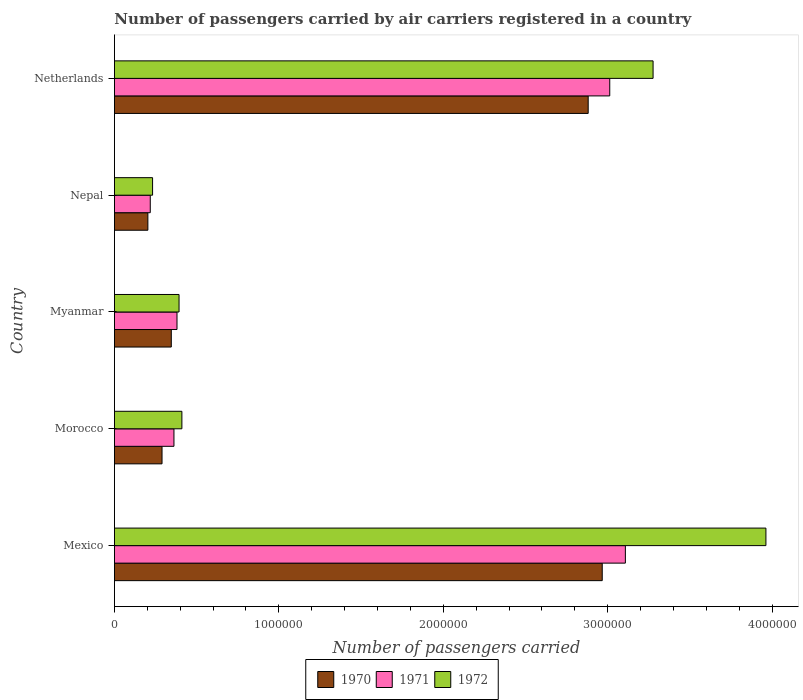Are the number of bars on each tick of the Y-axis equal?
Offer a terse response. Yes. How many bars are there on the 3rd tick from the top?
Provide a succinct answer. 3. How many bars are there on the 1st tick from the bottom?
Provide a short and direct response. 3. What is the label of the 2nd group of bars from the top?
Provide a short and direct response. Nepal. What is the number of passengers carried by air carriers in 1971 in Morocco?
Your answer should be very brief. 3.62e+05. Across all countries, what is the maximum number of passengers carried by air carriers in 1970?
Ensure brevity in your answer.  2.97e+06. Across all countries, what is the minimum number of passengers carried by air carriers in 1972?
Provide a short and direct response. 2.32e+05. In which country was the number of passengers carried by air carriers in 1971 maximum?
Your response must be concise. Mexico. In which country was the number of passengers carried by air carriers in 1971 minimum?
Offer a very short reply. Nepal. What is the total number of passengers carried by air carriers in 1972 in the graph?
Offer a terse response. 8.27e+06. What is the difference between the number of passengers carried by air carriers in 1971 in Morocco and that in Myanmar?
Offer a very short reply. -1.85e+04. What is the difference between the number of passengers carried by air carriers in 1970 in Myanmar and the number of passengers carried by air carriers in 1972 in Nepal?
Keep it short and to the point. 1.14e+05. What is the average number of passengers carried by air carriers in 1970 per country?
Ensure brevity in your answer.  1.34e+06. What is the difference between the number of passengers carried by air carriers in 1970 and number of passengers carried by air carriers in 1971 in Mexico?
Your answer should be very brief. -1.41e+05. In how many countries, is the number of passengers carried by air carriers in 1972 greater than 400000 ?
Ensure brevity in your answer.  3. What is the ratio of the number of passengers carried by air carriers in 1971 in Mexico to that in Myanmar?
Provide a succinct answer. 8.17. Is the number of passengers carried by air carriers in 1972 in Mexico less than that in Nepal?
Offer a very short reply. No. Is the difference between the number of passengers carried by air carriers in 1970 in Morocco and Nepal greater than the difference between the number of passengers carried by air carriers in 1971 in Morocco and Nepal?
Keep it short and to the point. No. What is the difference between the highest and the second highest number of passengers carried by air carriers in 1971?
Your answer should be very brief. 9.50e+04. What is the difference between the highest and the lowest number of passengers carried by air carriers in 1971?
Keep it short and to the point. 2.89e+06. In how many countries, is the number of passengers carried by air carriers in 1972 greater than the average number of passengers carried by air carriers in 1972 taken over all countries?
Keep it short and to the point. 2. What does the 3rd bar from the top in Mexico represents?
Provide a succinct answer. 1970. What does the 2nd bar from the bottom in Mexico represents?
Your answer should be compact. 1971. How many bars are there?
Give a very brief answer. 15. How many countries are there in the graph?
Provide a short and direct response. 5. Does the graph contain any zero values?
Your answer should be compact. No. Where does the legend appear in the graph?
Your answer should be compact. Bottom center. How many legend labels are there?
Give a very brief answer. 3. What is the title of the graph?
Make the answer very short. Number of passengers carried by air carriers registered in a country. What is the label or title of the X-axis?
Your answer should be very brief. Number of passengers carried. What is the Number of passengers carried in 1970 in Mexico?
Your response must be concise. 2.97e+06. What is the Number of passengers carried in 1971 in Mexico?
Provide a short and direct response. 3.11e+06. What is the Number of passengers carried of 1972 in Mexico?
Keep it short and to the point. 3.96e+06. What is the Number of passengers carried in 1970 in Morocco?
Your answer should be compact. 2.90e+05. What is the Number of passengers carried of 1971 in Morocco?
Your answer should be very brief. 3.62e+05. What is the Number of passengers carried of 1972 in Morocco?
Give a very brief answer. 4.10e+05. What is the Number of passengers carried in 1970 in Myanmar?
Your answer should be compact. 3.46e+05. What is the Number of passengers carried of 1971 in Myanmar?
Ensure brevity in your answer.  3.80e+05. What is the Number of passengers carried in 1972 in Myanmar?
Provide a succinct answer. 3.93e+05. What is the Number of passengers carried in 1970 in Nepal?
Offer a very short reply. 2.03e+05. What is the Number of passengers carried in 1971 in Nepal?
Offer a terse response. 2.18e+05. What is the Number of passengers carried of 1972 in Nepal?
Provide a short and direct response. 2.32e+05. What is the Number of passengers carried of 1970 in Netherlands?
Ensure brevity in your answer.  2.88e+06. What is the Number of passengers carried in 1971 in Netherlands?
Offer a very short reply. 3.01e+06. What is the Number of passengers carried in 1972 in Netherlands?
Offer a terse response. 3.28e+06. Across all countries, what is the maximum Number of passengers carried in 1970?
Provide a short and direct response. 2.97e+06. Across all countries, what is the maximum Number of passengers carried in 1971?
Offer a very short reply. 3.11e+06. Across all countries, what is the maximum Number of passengers carried in 1972?
Keep it short and to the point. 3.96e+06. Across all countries, what is the minimum Number of passengers carried of 1970?
Your response must be concise. 2.03e+05. Across all countries, what is the minimum Number of passengers carried in 1971?
Ensure brevity in your answer.  2.18e+05. Across all countries, what is the minimum Number of passengers carried in 1972?
Your answer should be very brief. 2.32e+05. What is the total Number of passengers carried in 1970 in the graph?
Give a very brief answer. 6.69e+06. What is the total Number of passengers carried of 1971 in the graph?
Offer a very short reply. 7.08e+06. What is the total Number of passengers carried in 1972 in the graph?
Offer a terse response. 8.27e+06. What is the difference between the Number of passengers carried in 1970 in Mexico and that in Morocco?
Provide a succinct answer. 2.68e+06. What is the difference between the Number of passengers carried in 1971 in Mexico and that in Morocco?
Your response must be concise. 2.75e+06. What is the difference between the Number of passengers carried of 1972 in Mexico and that in Morocco?
Make the answer very short. 3.55e+06. What is the difference between the Number of passengers carried of 1970 in Mexico and that in Myanmar?
Make the answer very short. 2.62e+06. What is the difference between the Number of passengers carried of 1971 in Mexico and that in Myanmar?
Ensure brevity in your answer.  2.73e+06. What is the difference between the Number of passengers carried of 1972 in Mexico and that in Myanmar?
Offer a very short reply. 3.57e+06. What is the difference between the Number of passengers carried in 1970 in Mexico and that in Nepal?
Provide a succinct answer. 2.76e+06. What is the difference between the Number of passengers carried of 1971 in Mexico and that in Nepal?
Provide a succinct answer. 2.89e+06. What is the difference between the Number of passengers carried of 1972 in Mexico and that in Nepal?
Keep it short and to the point. 3.73e+06. What is the difference between the Number of passengers carried of 1970 in Mexico and that in Netherlands?
Give a very brief answer. 8.55e+04. What is the difference between the Number of passengers carried of 1971 in Mexico and that in Netherlands?
Keep it short and to the point. 9.50e+04. What is the difference between the Number of passengers carried of 1972 in Mexico and that in Netherlands?
Offer a terse response. 6.86e+05. What is the difference between the Number of passengers carried of 1970 in Morocco and that in Myanmar?
Offer a very short reply. -5.63e+04. What is the difference between the Number of passengers carried of 1971 in Morocco and that in Myanmar?
Your response must be concise. -1.85e+04. What is the difference between the Number of passengers carried in 1972 in Morocco and that in Myanmar?
Keep it short and to the point. 1.73e+04. What is the difference between the Number of passengers carried of 1970 in Morocco and that in Nepal?
Offer a terse response. 8.61e+04. What is the difference between the Number of passengers carried of 1971 in Morocco and that in Nepal?
Give a very brief answer. 1.44e+05. What is the difference between the Number of passengers carried of 1972 in Morocco and that in Nepal?
Give a very brief answer. 1.78e+05. What is the difference between the Number of passengers carried in 1970 in Morocco and that in Netherlands?
Give a very brief answer. -2.59e+06. What is the difference between the Number of passengers carried in 1971 in Morocco and that in Netherlands?
Your answer should be compact. -2.65e+06. What is the difference between the Number of passengers carried in 1972 in Morocco and that in Netherlands?
Provide a short and direct response. -2.87e+06. What is the difference between the Number of passengers carried in 1970 in Myanmar and that in Nepal?
Provide a short and direct response. 1.42e+05. What is the difference between the Number of passengers carried of 1971 in Myanmar and that in Nepal?
Your answer should be compact. 1.63e+05. What is the difference between the Number of passengers carried of 1972 in Myanmar and that in Nepal?
Give a very brief answer. 1.61e+05. What is the difference between the Number of passengers carried of 1970 in Myanmar and that in Netherlands?
Offer a very short reply. -2.54e+06. What is the difference between the Number of passengers carried in 1971 in Myanmar and that in Netherlands?
Keep it short and to the point. -2.63e+06. What is the difference between the Number of passengers carried of 1972 in Myanmar and that in Netherlands?
Your answer should be very brief. -2.88e+06. What is the difference between the Number of passengers carried in 1970 in Nepal and that in Netherlands?
Give a very brief answer. -2.68e+06. What is the difference between the Number of passengers carried of 1971 in Nepal and that in Netherlands?
Make the answer very short. -2.79e+06. What is the difference between the Number of passengers carried of 1972 in Nepal and that in Netherlands?
Provide a short and direct response. -3.04e+06. What is the difference between the Number of passengers carried in 1970 in Mexico and the Number of passengers carried in 1971 in Morocco?
Provide a succinct answer. 2.60e+06. What is the difference between the Number of passengers carried in 1970 in Mexico and the Number of passengers carried in 1972 in Morocco?
Ensure brevity in your answer.  2.56e+06. What is the difference between the Number of passengers carried of 1971 in Mexico and the Number of passengers carried of 1972 in Morocco?
Offer a terse response. 2.70e+06. What is the difference between the Number of passengers carried in 1970 in Mexico and the Number of passengers carried in 1971 in Myanmar?
Provide a short and direct response. 2.59e+06. What is the difference between the Number of passengers carried of 1970 in Mexico and the Number of passengers carried of 1972 in Myanmar?
Offer a very short reply. 2.57e+06. What is the difference between the Number of passengers carried of 1971 in Mexico and the Number of passengers carried of 1972 in Myanmar?
Make the answer very short. 2.71e+06. What is the difference between the Number of passengers carried of 1970 in Mexico and the Number of passengers carried of 1971 in Nepal?
Give a very brief answer. 2.75e+06. What is the difference between the Number of passengers carried in 1970 in Mexico and the Number of passengers carried in 1972 in Nepal?
Offer a terse response. 2.73e+06. What is the difference between the Number of passengers carried in 1971 in Mexico and the Number of passengers carried in 1972 in Nepal?
Keep it short and to the point. 2.88e+06. What is the difference between the Number of passengers carried in 1970 in Mexico and the Number of passengers carried in 1971 in Netherlands?
Make the answer very short. -4.57e+04. What is the difference between the Number of passengers carried in 1970 in Mexico and the Number of passengers carried in 1972 in Netherlands?
Provide a succinct answer. -3.09e+05. What is the difference between the Number of passengers carried of 1971 in Mexico and the Number of passengers carried of 1972 in Netherlands?
Make the answer very short. -1.68e+05. What is the difference between the Number of passengers carried in 1970 in Morocco and the Number of passengers carried in 1971 in Myanmar?
Offer a very short reply. -9.10e+04. What is the difference between the Number of passengers carried of 1970 in Morocco and the Number of passengers carried of 1972 in Myanmar?
Make the answer very short. -1.04e+05. What is the difference between the Number of passengers carried of 1971 in Morocco and the Number of passengers carried of 1972 in Myanmar?
Ensure brevity in your answer.  -3.10e+04. What is the difference between the Number of passengers carried in 1970 in Morocco and the Number of passengers carried in 1971 in Nepal?
Keep it short and to the point. 7.16e+04. What is the difference between the Number of passengers carried of 1970 in Morocco and the Number of passengers carried of 1972 in Nepal?
Offer a terse response. 5.75e+04. What is the difference between the Number of passengers carried in 1971 in Morocco and the Number of passengers carried in 1972 in Nepal?
Give a very brief answer. 1.30e+05. What is the difference between the Number of passengers carried of 1970 in Morocco and the Number of passengers carried of 1971 in Netherlands?
Offer a very short reply. -2.72e+06. What is the difference between the Number of passengers carried in 1970 in Morocco and the Number of passengers carried in 1972 in Netherlands?
Make the answer very short. -2.99e+06. What is the difference between the Number of passengers carried in 1971 in Morocco and the Number of passengers carried in 1972 in Netherlands?
Ensure brevity in your answer.  -2.91e+06. What is the difference between the Number of passengers carried of 1970 in Myanmar and the Number of passengers carried of 1971 in Nepal?
Provide a short and direct response. 1.28e+05. What is the difference between the Number of passengers carried of 1970 in Myanmar and the Number of passengers carried of 1972 in Nepal?
Provide a succinct answer. 1.14e+05. What is the difference between the Number of passengers carried of 1971 in Myanmar and the Number of passengers carried of 1972 in Nepal?
Offer a terse response. 1.48e+05. What is the difference between the Number of passengers carried in 1970 in Myanmar and the Number of passengers carried in 1971 in Netherlands?
Provide a short and direct response. -2.67e+06. What is the difference between the Number of passengers carried in 1970 in Myanmar and the Number of passengers carried in 1972 in Netherlands?
Provide a succinct answer. -2.93e+06. What is the difference between the Number of passengers carried of 1971 in Myanmar and the Number of passengers carried of 1972 in Netherlands?
Offer a terse response. -2.90e+06. What is the difference between the Number of passengers carried in 1970 in Nepal and the Number of passengers carried in 1971 in Netherlands?
Your answer should be very brief. -2.81e+06. What is the difference between the Number of passengers carried of 1970 in Nepal and the Number of passengers carried of 1972 in Netherlands?
Your answer should be very brief. -3.07e+06. What is the difference between the Number of passengers carried of 1971 in Nepal and the Number of passengers carried of 1972 in Netherlands?
Your response must be concise. -3.06e+06. What is the average Number of passengers carried in 1970 per country?
Ensure brevity in your answer.  1.34e+06. What is the average Number of passengers carried in 1971 per country?
Make the answer very short. 1.42e+06. What is the average Number of passengers carried in 1972 per country?
Provide a short and direct response. 1.65e+06. What is the difference between the Number of passengers carried of 1970 and Number of passengers carried of 1971 in Mexico?
Your answer should be very brief. -1.41e+05. What is the difference between the Number of passengers carried in 1970 and Number of passengers carried in 1972 in Mexico?
Your response must be concise. -9.95e+05. What is the difference between the Number of passengers carried of 1971 and Number of passengers carried of 1972 in Mexico?
Your answer should be compact. -8.55e+05. What is the difference between the Number of passengers carried in 1970 and Number of passengers carried in 1971 in Morocco?
Provide a succinct answer. -7.25e+04. What is the difference between the Number of passengers carried of 1970 and Number of passengers carried of 1972 in Morocco?
Ensure brevity in your answer.  -1.21e+05. What is the difference between the Number of passengers carried of 1971 and Number of passengers carried of 1972 in Morocco?
Keep it short and to the point. -4.83e+04. What is the difference between the Number of passengers carried of 1970 and Number of passengers carried of 1971 in Myanmar?
Offer a terse response. -3.47e+04. What is the difference between the Number of passengers carried of 1970 and Number of passengers carried of 1972 in Myanmar?
Offer a terse response. -4.72e+04. What is the difference between the Number of passengers carried of 1971 and Number of passengers carried of 1972 in Myanmar?
Provide a succinct answer. -1.25e+04. What is the difference between the Number of passengers carried in 1970 and Number of passengers carried in 1971 in Nepal?
Make the answer very short. -1.45e+04. What is the difference between the Number of passengers carried of 1970 and Number of passengers carried of 1972 in Nepal?
Make the answer very short. -2.86e+04. What is the difference between the Number of passengers carried in 1971 and Number of passengers carried in 1972 in Nepal?
Provide a short and direct response. -1.41e+04. What is the difference between the Number of passengers carried of 1970 and Number of passengers carried of 1971 in Netherlands?
Your response must be concise. -1.31e+05. What is the difference between the Number of passengers carried in 1970 and Number of passengers carried in 1972 in Netherlands?
Provide a succinct answer. -3.95e+05. What is the difference between the Number of passengers carried in 1971 and Number of passengers carried in 1972 in Netherlands?
Your answer should be compact. -2.64e+05. What is the ratio of the Number of passengers carried of 1970 in Mexico to that in Morocco?
Give a very brief answer. 10.25. What is the ratio of the Number of passengers carried of 1971 in Mexico to that in Morocco?
Make the answer very short. 8.58. What is the ratio of the Number of passengers carried in 1972 in Mexico to that in Morocco?
Offer a very short reply. 9.66. What is the ratio of the Number of passengers carried in 1970 in Mexico to that in Myanmar?
Ensure brevity in your answer.  8.58. What is the ratio of the Number of passengers carried in 1971 in Mexico to that in Myanmar?
Give a very brief answer. 8.17. What is the ratio of the Number of passengers carried in 1972 in Mexico to that in Myanmar?
Make the answer very short. 10.08. What is the ratio of the Number of passengers carried of 1970 in Mexico to that in Nepal?
Your answer should be very brief. 14.59. What is the ratio of the Number of passengers carried of 1971 in Mexico to that in Nepal?
Your response must be concise. 14.26. What is the ratio of the Number of passengers carried of 1972 in Mexico to that in Nepal?
Offer a terse response. 17.08. What is the ratio of the Number of passengers carried of 1970 in Mexico to that in Netherlands?
Offer a terse response. 1.03. What is the ratio of the Number of passengers carried in 1971 in Mexico to that in Netherlands?
Keep it short and to the point. 1.03. What is the ratio of the Number of passengers carried in 1972 in Mexico to that in Netherlands?
Offer a terse response. 1.21. What is the ratio of the Number of passengers carried of 1970 in Morocco to that in Myanmar?
Keep it short and to the point. 0.84. What is the ratio of the Number of passengers carried of 1971 in Morocco to that in Myanmar?
Keep it short and to the point. 0.95. What is the ratio of the Number of passengers carried of 1972 in Morocco to that in Myanmar?
Give a very brief answer. 1.04. What is the ratio of the Number of passengers carried of 1970 in Morocco to that in Nepal?
Give a very brief answer. 1.42. What is the ratio of the Number of passengers carried in 1971 in Morocco to that in Nepal?
Make the answer very short. 1.66. What is the ratio of the Number of passengers carried in 1972 in Morocco to that in Nepal?
Keep it short and to the point. 1.77. What is the ratio of the Number of passengers carried of 1970 in Morocco to that in Netherlands?
Keep it short and to the point. 0.1. What is the ratio of the Number of passengers carried in 1971 in Morocco to that in Netherlands?
Keep it short and to the point. 0.12. What is the ratio of the Number of passengers carried in 1972 in Morocco to that in Netherlands?
Your response must be concise. 0.13. What is the ratio of the Number of passengers carried of 1970 in Myanmar to that in Nepal?
Your response must be concise. 1.7. What is the ratio of the Number of passengers carried in 1971 in Myanmar to that in Nepal?
Your answer should be very brief. 1.75. What is the ratio of the Number of passengers carried of 1972 in Myanmar to that in Nepal?
Offer a very short reply. 1.69. What is the ratio of the Number of passengers carried in 1970 in Myanmar to that in Netherlands?
Keep it short and to the point. 0.12. What is the ratio of the Number of passengers carried of 1971 in Myanmar to that in Netherlands?
Offer a terse response. 0.13. What is the ratio of the Number of passengers carried of 1972 in Myanmar to that in Netherlands?
Offer a terse response. 0.12. What is the ratio of the Number of passengers carried in 1970 in Nepal to that in Netherlands?
Keep it short and to the point. 0.07. What is the ratio of the Number of passengers carried in 1971 in Nepal to that in Netherlands?
Make the answer very short. 0.07. What is the ratio of the Number of passengers carried in 1972 in Nepal to that in Netherlands?
Ensure brevity in your answer.  0.07. What is the difference between the highest and the second highest Number of passengers carried in 1970?
Ensure brevity in your answer.  8.55e+04. What is the difference between the highest and the second highest Number of passengers carried in 1971?
Your response must be concise. 9.50e+04. What is the difference between the highest and the second highest Number of passengers carried in 1972?
Make the answer very short. 6.86e+05. What is the difference between the highest and the lowest Number of passengers carried in 1970?
Keep it short and to the point. 2.76e+06. What is the difference between the highest and the lowest Number of passengers carried of 1971?
Offer a terse response. 2.89e+06. What is the difference between the highest and the lowest Number of passengers carried of 1972?
Ensure brevity in your answer.  3.73e+06. 